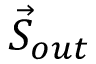<formula> <loc_0><loc_0><loc_500><loc_500>\vec { S } _ { o u t }</formula> 